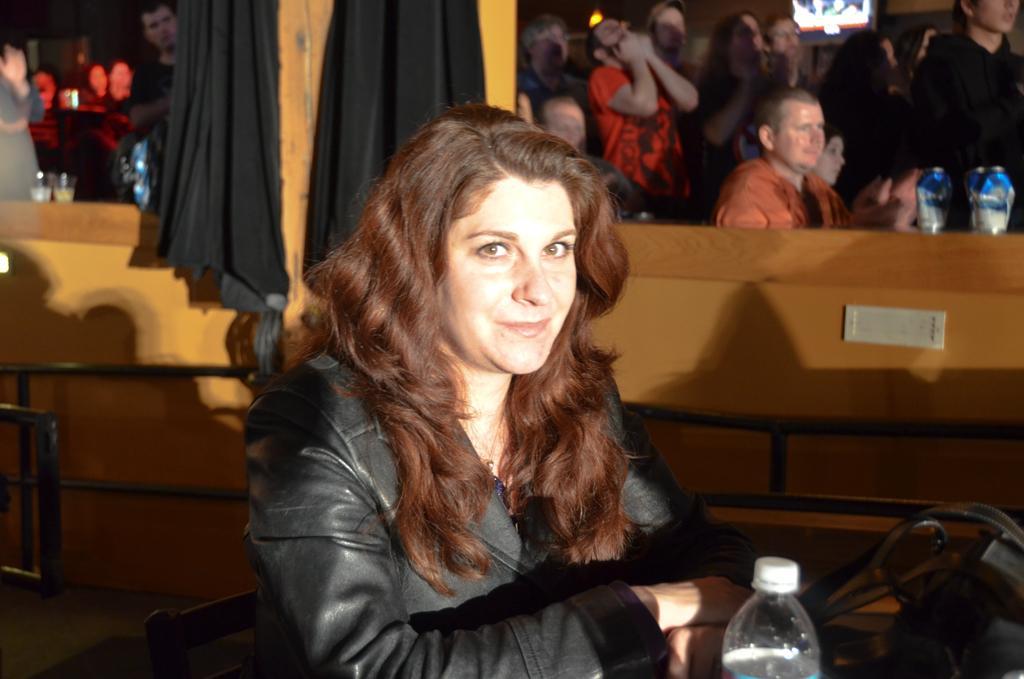Describe this image in one or two sentences. In this image we have a woman who is wearing a black jacket and smiling. Here we have water bottle and a bag. Behind the women we have a group of people. 